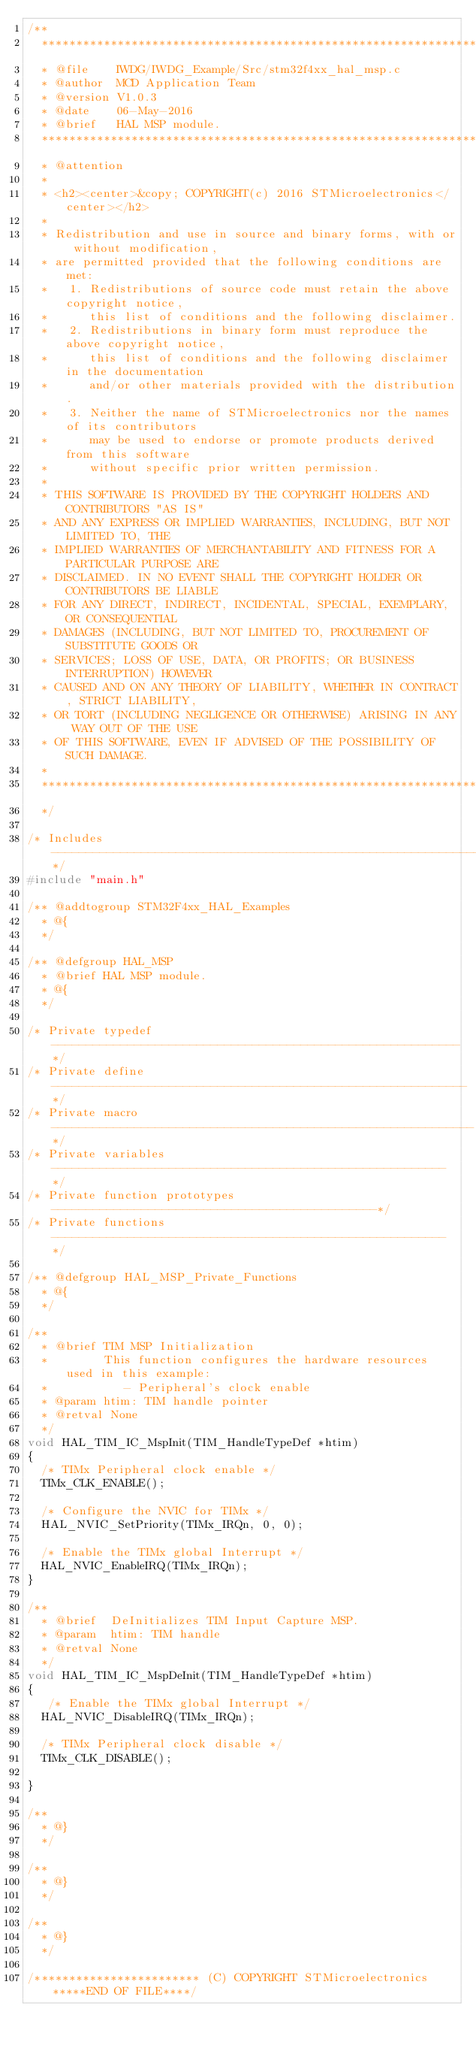Convert code to text. <code><loc_0><loc_0><loc_500><loc_500><_C_>/**
  ******************************************************************************
  * @file    IWDG/IWDG_Example/Src/stm32f4xx_hal_msp.c
  * @author  MCD Application Team
  * @version V1.0.3
  * @date    06-May-2016
  * @brief   HAL MSP module.
  ******************************************************************************
  * @attention
  *
  * <h2><center>&copy; COPYRIGHT(c) 2016 STMicroelectronics</center></h2>
  *
  * Redistribution and use in source and binary forms, with or without modification,
  * are permitted provided that the following conditions are met:
  *   1. Redistributions of source code must retain the above copyright notice,
  *      this list of conditions and the following disclaimer.
  *   2. Redistributions in binary form must reproduce the above copyright notice,
  *      this list of conditions and the following disclaimer in the documentation
  *      and/or other materials provided with the distribution.
  *   3. Neither the name of STMicroelectronics nor the names of its contributors
  *      may be used to endorse or promote products derived from this software
  *      without specific prior written permission.
  *
  * THIS SOFTWARE IS PROVIDED BY THE COPYRIGHT HOLDERS AND CONTRIBUTORS "AS IS"
  * AND ANY EXPRESS OR IMPLIED WARRANTIES, INCLUDING, BUT NOT LIMITED TO, THE
  * IMPLIED WARRANTIES OF MERCHANTABILITY AND FITNESS FOR A PARTICULAR PURPOSE ARE
  * DISCLAIMED. IN NO EVENT SHALL THE COPYRIGHT HOLDER OR CONTRIBUTORS BE LIABLE
  * FOR ANY DIRECT, INDIRECT, INCIDENTAL, SPECIAL, EXEMPLARY, OR CONSEQUENTIAL
  * DAMAGES (INCLUDING, BUT NOT LIMITED TO, PROCUREMENT OF SUBSTITUTE GOODS OR
  * SERVICES; LOSS OF USE, DATA, OR PROFITS; OR BUSINESS INTERRUPTION) HOWEVER
  * CAUSED AND ON ANY THEORY OF LIABILITY, WHETHER IN CONTRACT, STRICT LIABILITY,
  * OR TORT (INCLUDING NEGLIGENCE OR OTHERWISE) ARISING IN ANY WAY OUT OF THE USE
  * OF THIS SOFTWARE, EVEN IF ADVISED OF THE POSSIBILITY OF SUCH DAMAGE.
  *
  ******************************************************************************
  */

/* Includes ------------------------------------------------------------------*/
#include "main.h"

/** @addtogroup STM32F4xx_HAL_Examples
  * @{
  */

/** @defgroup HAL_MSP
  * @brief HAL MSP module.
  * @{
  */

/* Private typedef -----------------------------------------------------------*/
/* Private define ------------------------------------------------------------*/
/* Private macro -------------------------------------------------------------*/
/* Private variables ---------------------------------------------------------*/
/* Private function prototypes -----------------------------------------------*/
/* Private functions ---------------------------------------------------------*/

/** @defgroup HAL_MSP_Private_Functions
  * @{
  */

/**
  * @brief TIM MSP Initialization
  *        This function configures the hardware resources used in this example:
  *           - Peripheral's clock enable
  * @param htim: TIM handle pointer
  * @retval None
  */
void HAL_TIM_IC_MspInit(TIM_HandleTypeDef *htim)
{
  /* TIMx Peripheral clock enable */
  TIMx_CLK_ENABLE();

  /* Configure the NVIC for TIMx */
  HAL_NVIC_SetPriority(TIMx_IRQn, 0, 0);

  /* Enable the TIMx global Interrupt */
  HAL_NVIC_EnableIRQ(TIMx_IRQn);
}

/**
  * @brief  DeInitializes TIM Input Capture MSP.
  * @param  htim: TIM handle
  * @retval None
  */
void HAL_TIM_IC_MspDeInit(TIM_HandleTypeDef *htim)
{
   /* Enable the TIMx global Interrupt */
  HAL_NVIC_DisableIRQ(TIMx_IRQn);
  
  /* TIMx Peripheral clock disable */
  TIMx_CLK_DISABLE();

}

/**
  * @}
  */

/**
  * @}
  */

/**
  * @}
  */

/************************ (C) COPYRIGHT STMicroelectronics *****END OF FILE****/
</code> 